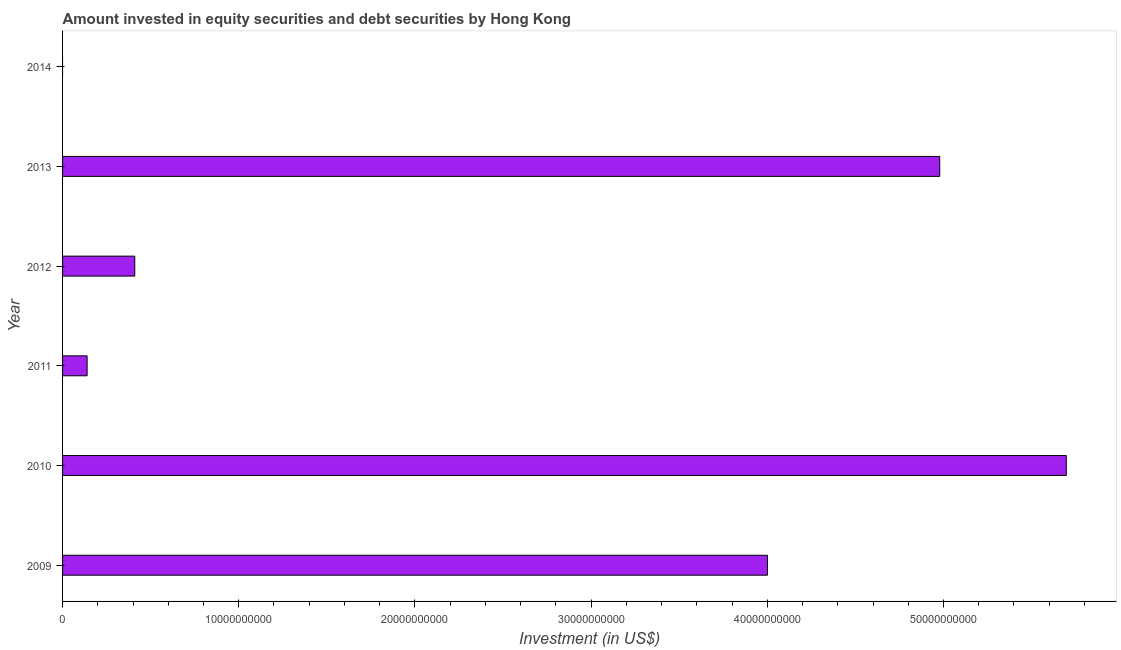Does the graph contain any zero values?
Provide a succinct answer. Yes. Does the graph contain grids?
Offer a very short reply. No. What is the title of the graph?
Ensure brevity in your answer.  Amount invested in equity securities and debt securities by Hong Kong. What is the label or title of the X-axis?
Your answer should be very brief. Investment (in US$). What is the portfolio investment in 2010?
Your response must be concise. 5.70e+1. Across all years, what is the maximum portfolio investment?
Keep it short and to the point. 5.70e+1. What is the sum of the portfolio investment?
Provide a short and direct response. 1.52e+11. What is the difference between the portfolio investment in 2010 and 2012?
Make the answer very short. 5.29e+1. What is the average portfolio investment per year?
Give a very brief answer. 2.54e+1. What is the median portfolio investment?
Provide a succinct answer. 2.21e+1. What is the ratio of the portfolio investment in 2010 to that in 2013?
Offer a terse response. 1.14. Is the portfolio investment in 2009 less than that in 2011?
Your response must be concise. No. What is the difference between the highest and the second highest portfolio investment?
Ensure brevity in your answer.  7.18e+09. What is the difference between the highest and the lowest portfolio investment?
Offer a terse response. 5.70e+1. In how many years, is the portfolio investment greater than the average portfolio investment taken over all years?
Your answer should be very brief. 3. How many bars are there?
Your response must be concise. 5. How many years are there in the graph?
Offer a very short reply. 6. What is the difference between two consecutive major ticks on the X-axis?
Make the answer very short. 1.00e+1. Are the values on the major ticks of X-axis written in scientific E-notation?
Make the answer very short. No. What is the Investment (in US$) of 2009?
Offer a very short reply. 4.00e+1. What is the Investment (in US$) of 2010?
Your answer should be compact. 5.70e+1. What is the Investment (in US$) of 2011?
Your answer should be very brief. 1.39e+09. What is the Investment (in US$) of 2012?
Your answer should be very brief. 4.10e+09. What is the Investment (in US$) of 2013?
Make the answer very short. 4.98e+1. What is the Investment (in US$) of 2014?
Your response must be concise. 0. What is the difference between the Investment (in US$) in 2009 and 2010?
Your answer should be compact. -1.70e+1. What is the difference between the Investment (in US$) in 2009 and 2011?
Keep it short and to the point. 3.86e+1. What is the difference between the Investment (in US$) in 2009 and 2012?
Offer a terse response. 3.59e+1. What is the difference between the Investment (in US$) in 2009 and 2013?
Your answer should be compact. -9.78e+09. What is the difference between the Investment (in US$) in 2010 and 2011?
Your response must be concise. 5.56e+1. What is the difference between the Investment (in US$) in 2010 and 2012?
Ensure brevity in your answer.  5.29e+1. What is the difference between the Investment (in US$) in 2010 and 2013?
Provide a short and direct response. 7.18e+09. What is the difference between the Investment (in US$) in 2011 and 2012?
Your response must be concise. -2.70e+09. What is the difference between the Investment (in US$) in 2011 and 2013?
Offer a very short reply. -4.84e+1. What is the difference between the Investment (in US$) in 2012 and 2013?
Offer a terse response. -4.57e+1. What is the ratio of the Investment (in US$) in 2009 to that in 2010?
Offer a terse response. 0.7. What is the ratio of the Investment (in US$) in 2009 to that in 2011?
Offer a terse response. 28.71. What is the ratio of the Investment (in US$) in 2009 to that in 2012?
Provide a short and direct response. 9.76. What is the ratio of the Investment (in US$) in 2009 to that in 2013?
Offer a very short reply. 0.8. What is the ratio of the Investment (in US$) in 2010 to that in 2011?
Your answer should be very brief. 40.89. What is the ratio of the Investment (in US$) in 2010 to that in 2012?
Ensure brevity in your answer.  13.9. What is the ratio of the Investment (in US$) in 2010 to that in 2013?
Give a very brief answer. 1.14. What is the ratio of the Investment (in US$) in 2011 to that in 2012?
Keep it short and to the point. 0.34. What is the ratio of the Investment (in US$) in 2011 to that in 2013?
Give a very brief answer. 0.03. What is the ratio of the Investment (in US$) in 2012 to that in 2013?
Give a very brief answer. 0.08. 